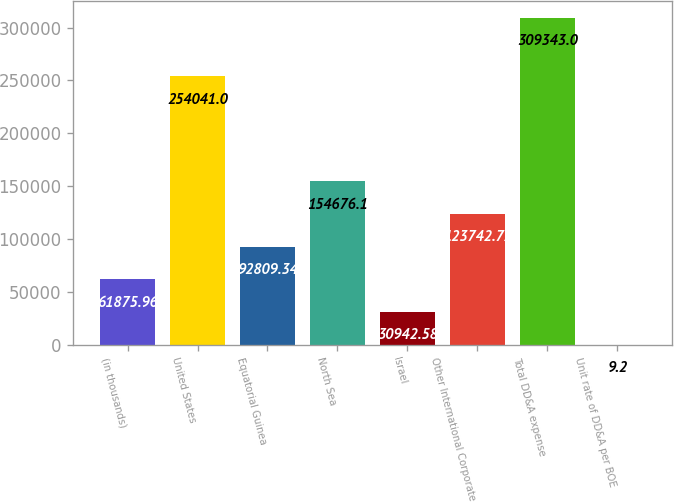<chart> <loc_0><loc_0><loc_500><loc_500><bar_chart><fcel>(in thousands)<fcel>United States<fcel>Equatorial Guinea<fcel>North Sea<fcel>Israel<fcel>Other International Corporate<fcel>Total DD&A expense<fcel>Unit rate of DD&A per BOE<nl><fcel>61876<fcel>254041<fcel>92809.3<fcel>154676<fcel>30942.6<fcel>123743<fcel>309343<fcel>9.2<nl></chart> 